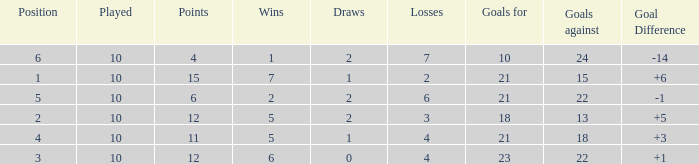Can you tell me the total number of Wins that has the Draws larger than 0, and the Points of 11? 1.0. 